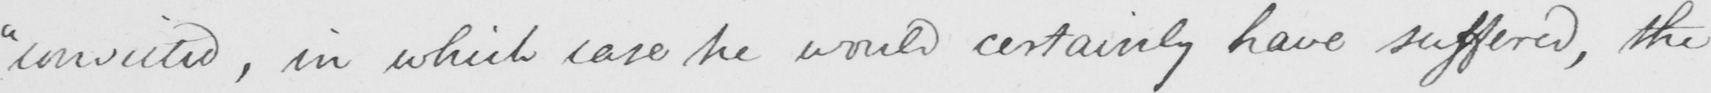What is written in this line of handwriting? " convicted , in which case he would certainly have suffered , the 